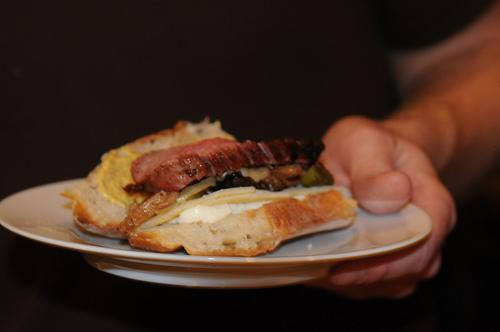What type of meat is present in the sandwich, and what is its condition? There is sliced meat on the sandwich, which appears to be grilled and greasy, like a hot dog cut into two pieces. What is the person in the image doing, and what object are they interacting with? The person, wearing a black shirt, is holding a small white plate containing a sandwich made of bread, meat, cheese, and other toppings. Enumerate the visible condiments on the sandwich and the type of bread it is served on. On the sandwich, there is mayonnaise, mustard, sliced onions, and pickles, served on a white bread roll. Describe any aspect of the image that might indicate it involves junk food. The sandwich contains a greasy, grilled hot dog, cheese, mayonnaise, and other condiments, which might indicate that it is a type of junk food. Provide a brief description of the plate, including its color and size, and what it is holding. The plate is small and white, and it is holding a sandwich made with meat, cheese, and other toppings on a white bread roll. What color is the shirt of the person holding the plate and what type of food is on the plate? The person is wearing a black shirt and there is a sandwich containing meat, cheese, and other condiments on the plate. Identify the type of food on the plate and describe its ingredients. A sandwich containing sliced meat, cheese, mayonnaise, mustard, onions, and pickles, served on a white bread roll, is placed on a white plate. List the toppings found between the two pieces of bread in the sandwich. The toppings include sliced meat, cheese slices, mayonnaise, mustard, onions, and green pickles. Describe in detail the outer appearance and characteristics of the bread. The bread is white, with a golden brown crust on its outer layer, and a soft, fluffy texture inside. Identify the main objects on the plate and describe any specific characteristics they may have. The main objects on the plate are an open sandwich made with a white bread roll, containing sliced meat, cheese, and various condiments, and the plate itself, which is small and white. 